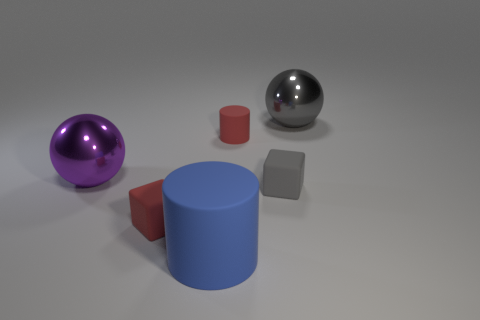Add 1 spheres. How many objects exist? 7 Subtract all cubes. How many objects are left? 4 Subtract 0 brown cylinders. How many objects are left? 6 Subtract all large gray metal objects. Subtract all tiny red rubber cubes. How many objects are left? 4 Add 6 small matte objects. How many small matte objects are left? 9 Add 2 red rubber cubes. How many red rubber cubes exist? 3 